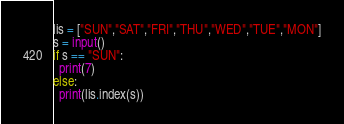<code> <loc_0><loc_0><loc_500><loc_500><_Python_>lis = ["SUN","SAT","FRI","THU","WED","TUE","MON"]
s = input()
if s == "SUN":
  print(7)
else:
  print(lis.index(s))</code> 